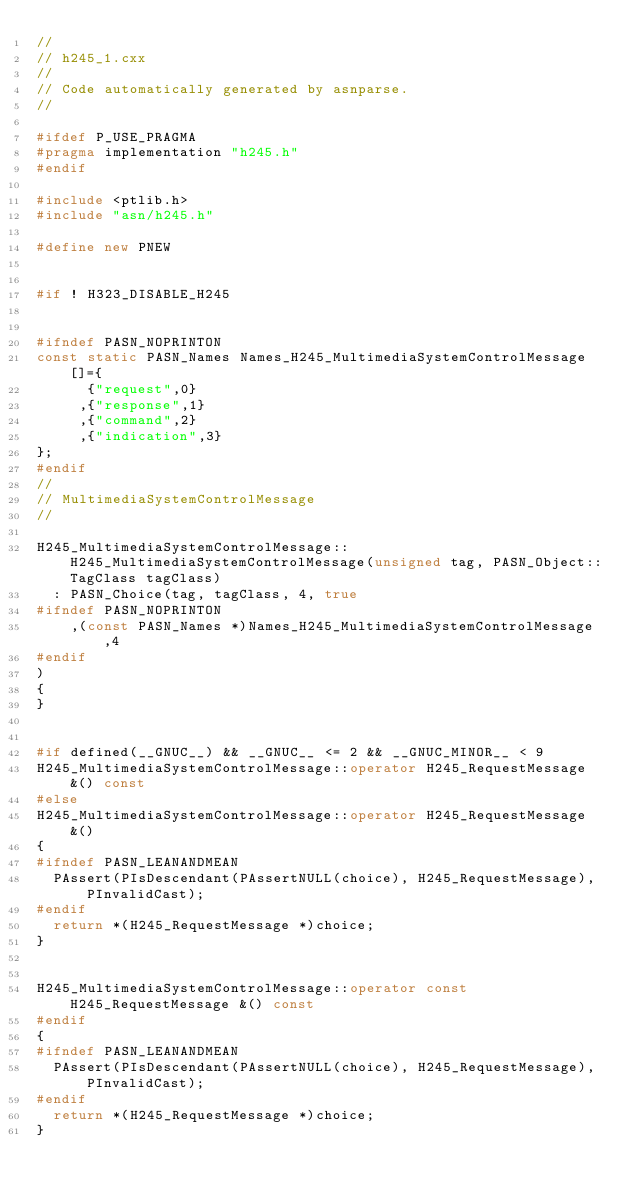Convert code to text. <code><loc_0><loc_0><loc_500><loc_500><_C++_>//
// h245_1.cxx
//
// Code automatically generated by asnparse.
//

#ifdef P_USE_PRAGMA
#pragma implementation "h245.h"
#endif

#include <ptlib.h>
#include "asn/h245.h"

#define new PNEW


#if ! H323_DISABLE_H245


#ifndef PASN_NOPRINTON
const static PASN_Names Names_H245_MultimediaSystemControlMessage[]={
      {"request",0}
     ,{"response",1}
     ,{"command",2}
     ,{"indication",3}
};
#endif
//
// MultimediaSystemControlMessage
//

H245_MultimediaSystemControlMessage::H245_MultimediaSystemControlMessage(unsigned tag, PASN_Object::TagClass tagClass)
  : PASN_Choice(tag, tagClass, 4, true
#ifndef PASN_NOPRINTON
    ,(const PASN_Names *)Names_H245_MultimediaSystemControlMessage,4
#endif
)
{
}


#if defined(__GNUC__) && __GNUC__ <= 2 && __GNUC_MINOR__ < 9
H245_MultimediaSystemControlMessage::operator H245_RequestMessage &() const
#else
H245_MultimediaSystemControlMessage::operator H245_RequestMessage &()
{
#ifndef PASN_LEANANDMEAN
  PAssert(PIsDescendant(PAssertNULL(choice), H245_RequestMessage), PInvalidCast);
#endif
  return *(H245_RequestMessage *)choice;
}


H245_MultimediaSystemControlMessage::operator const H245_RequestMessage &() const
#endif
{
#ifndef PASN_LEANANDMEAN
  PAssert(PIsDescendant(PAssertNULL(choice), H245_RequestMessage), PInvalidCast);
#endif
  return *(H245_RequestMessage *)choice;
}

</code> 